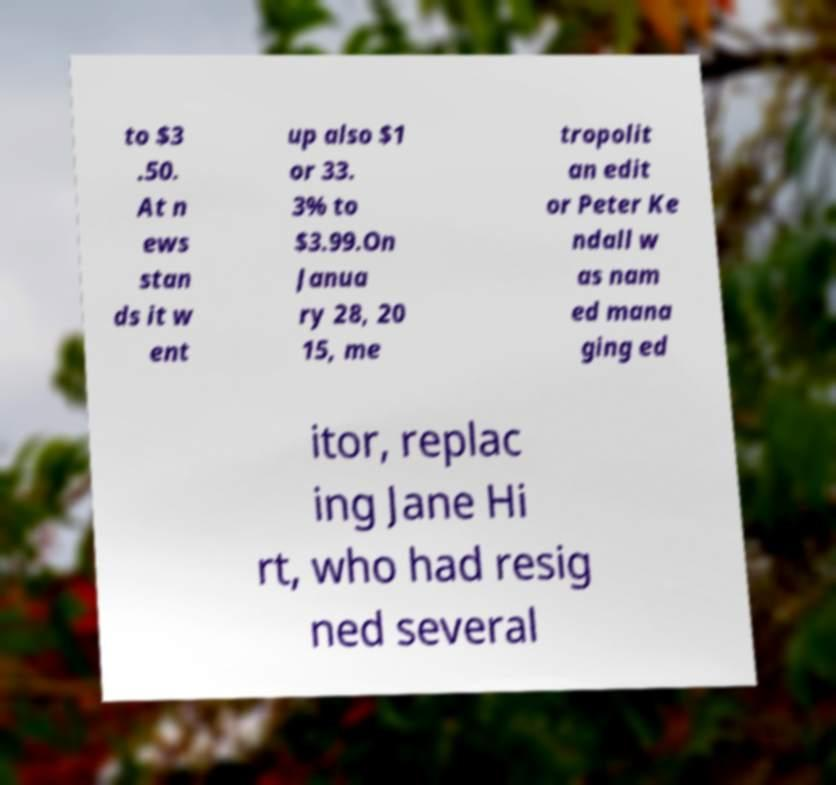I need the written content from this picture converted into text. Can you do that? to $3 .50. At n ews stan ds it w ent up also $1 or 33. 3% to $3.99.On Janua ry 28, 20 15, me tropolit an edit or Peter Ke ndall w as nam ed mana ging ed itor, replac ing Jane Hi rt, who had resig ned several 